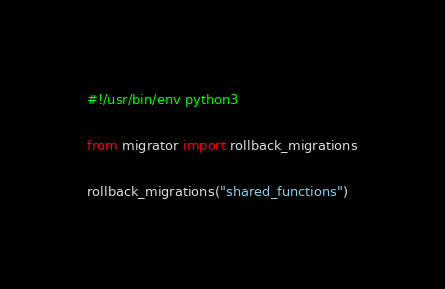Convert code to text. <code><loc_0><loc_0><loc_500><loc_500><_Python_>#!/usr/bin/env python3

from migrator import rollback_migrations

rollback_migrations("shared_functions")
</code> 